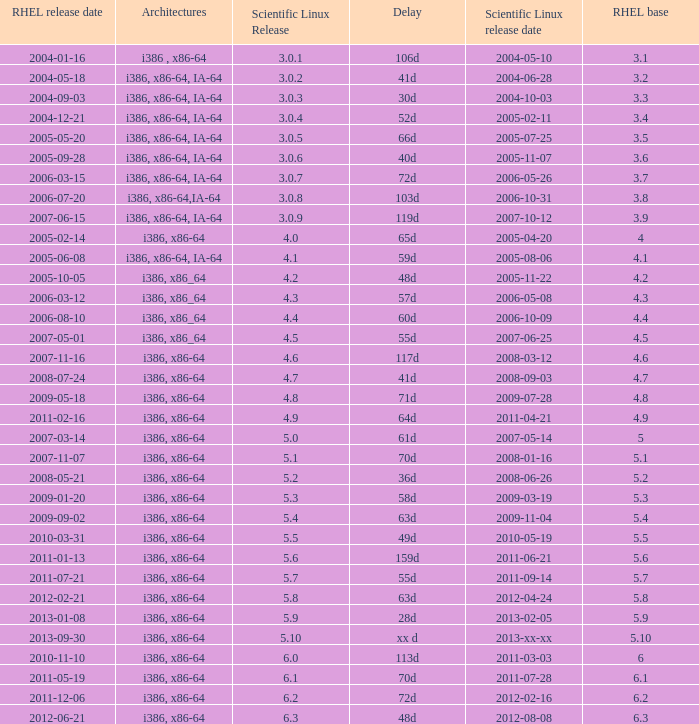Name the scientific linux release when delay is 28d 5.9. 